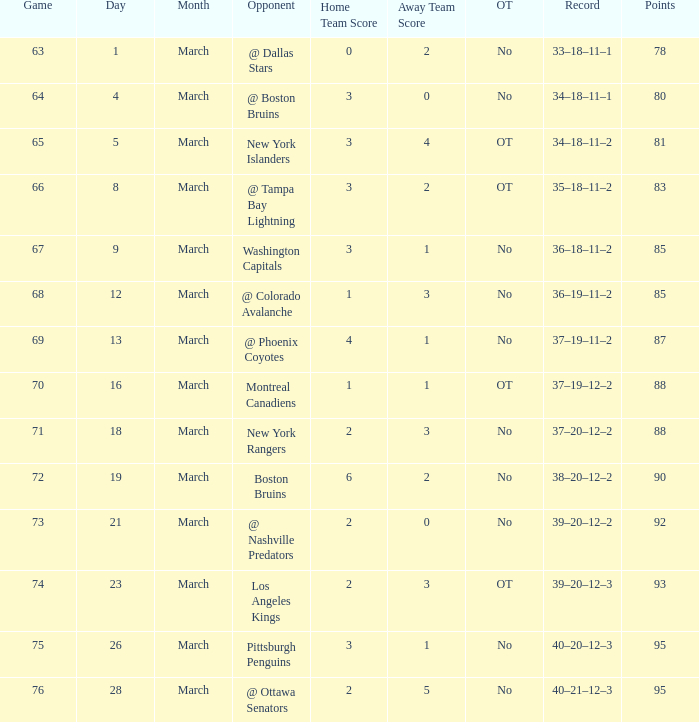How many Points have a Record of 40–21–12–3, and a March larger than 28? 0.0. 